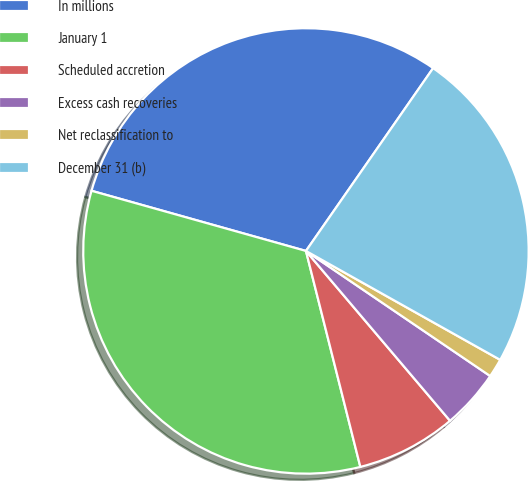Convert chart to OTSL. <chart><loc_0><loc_0><loc_500><loc_500><pie_chart><fcel>In millions<fcel>January 1<fcel>Scheduled accretion<fcel>Excess cash recoveries<fcel>Net reclassification to<fcel>December 31 (b)<nl><fcel>30.32%<fcel>33.28%<fcel>7.27%<fcel>4.31%<fcel>1.36%<fcel>23.46%<nl></chart> 